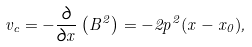Convert formula to latex. <formula><loc_0><loc_0><loc_500><loc_500>v _ { c } = - \frac { \partial } { \partial x } \left ( B ^ { 2 } \right ) = - 2 p ^ { 2 } ( x - x _ { 0 } ) ,</formula> 